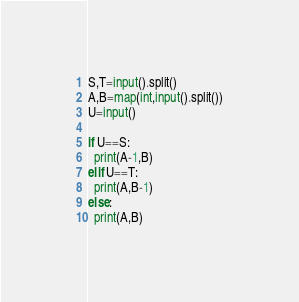<code> <loc_0><loc_0><loc_500><loc_500><_Python_>S,T=input().split()
A,B=map(int,input().split())
U=input()

if U==S:
  print(A-1,B)
elif U==T:
  print(A,B-1)
else:
  print(A,B)</code> 